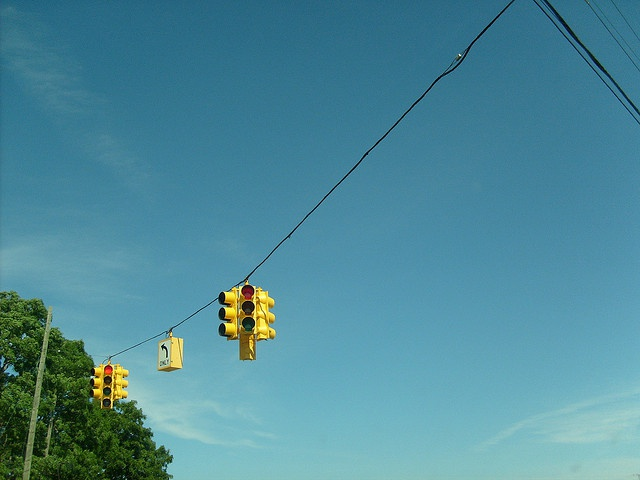Describe the objects in this image and their specific colors. I can see traffic light in teal, black, khaki, olive, and orange tones, traffic light in teal, black, olive, and khaki tones, traffic light in teal, gold, orange, and olive tones, and traffic light in teal, black, gold, olive, and orange tones in this image. 